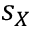Convert formula to latex. <formula><loc_0><loc_0><loc_500><loc_500>s _ { X }</formula> 